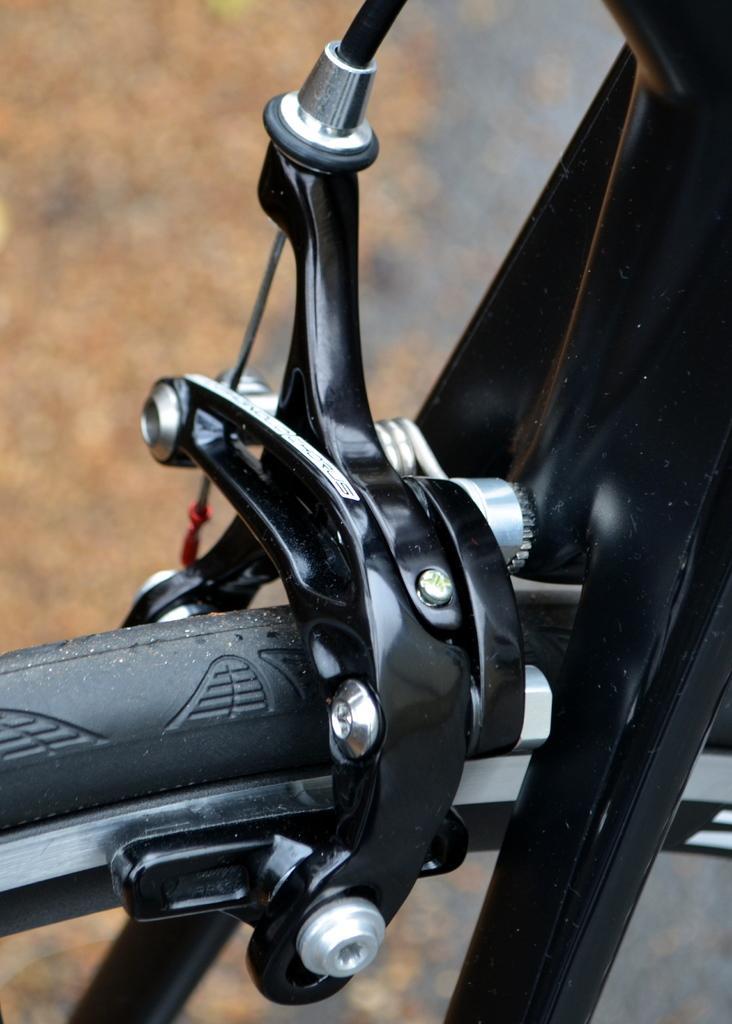In one or two sentences, can you explain what this image depicts? In the image we can see the break part of the bicycle and the background is blurred. 